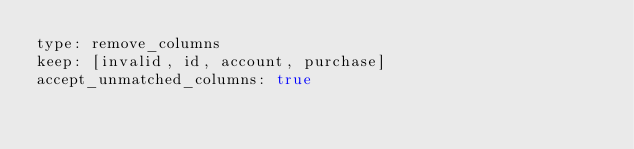Convert code to text. <code><loc_0><loc_0><loc_500><loc_500><_YAML_>type: remove_columns
keep: [invalid, id, account, purchase]
accept_unmatched_columns: true</code> 